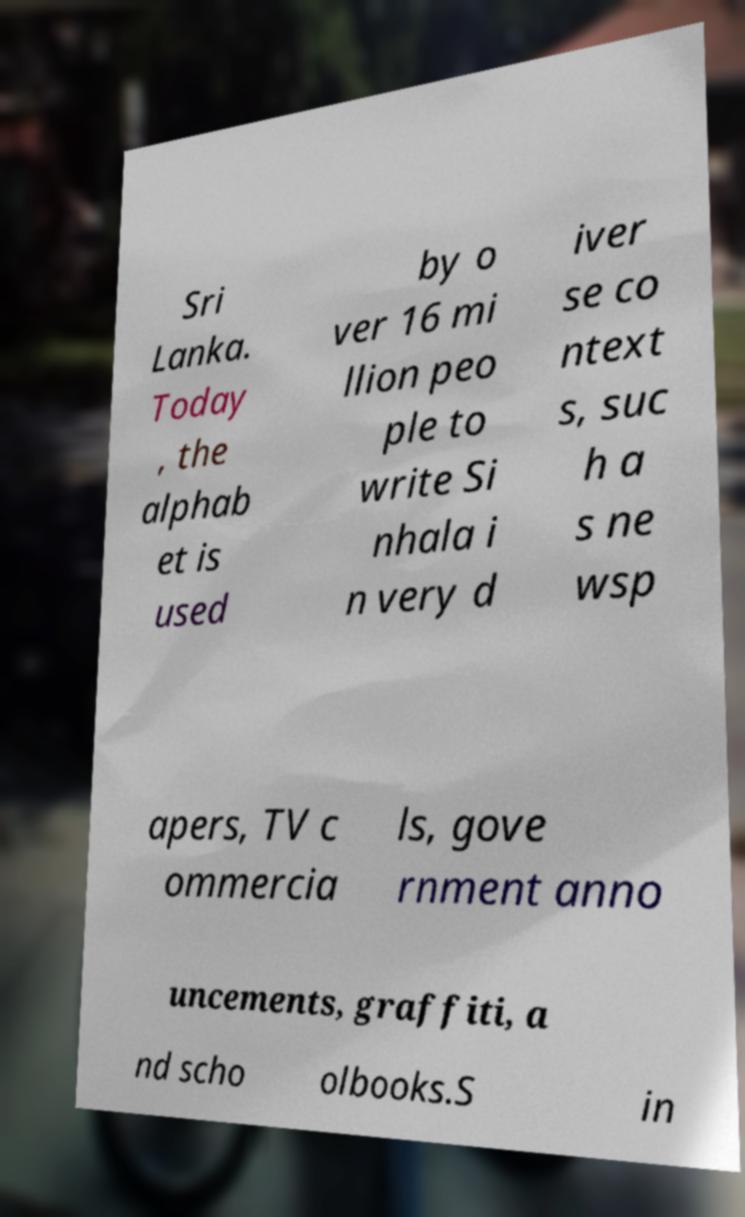There's text embedded in this image that I need extracted. Can you transcribe it verbatim? Sri Lanka. Today , the alphab et is used by o ver 16 mi llion peo ple to write Si nhala i n very d iver se co ntext s, suc h a s ne wsp apers, TV c ommercia ls, gove rnment anno uncements, graffiti, a nd scho olbooks.S in 